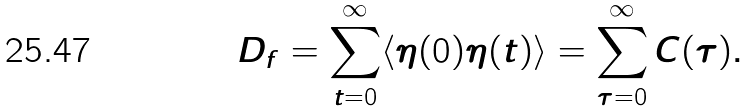<formula> <loc_0><loc_0><loc_500><loc_500>D _ { f } = \sum _ { t = 0 } ^ { \infty } \langle \eta ( 0 ) \eta ( t ) \rangle = \sum ^ { \infty } _ { \tau = 0 } C ( \tau ) .</formula> 